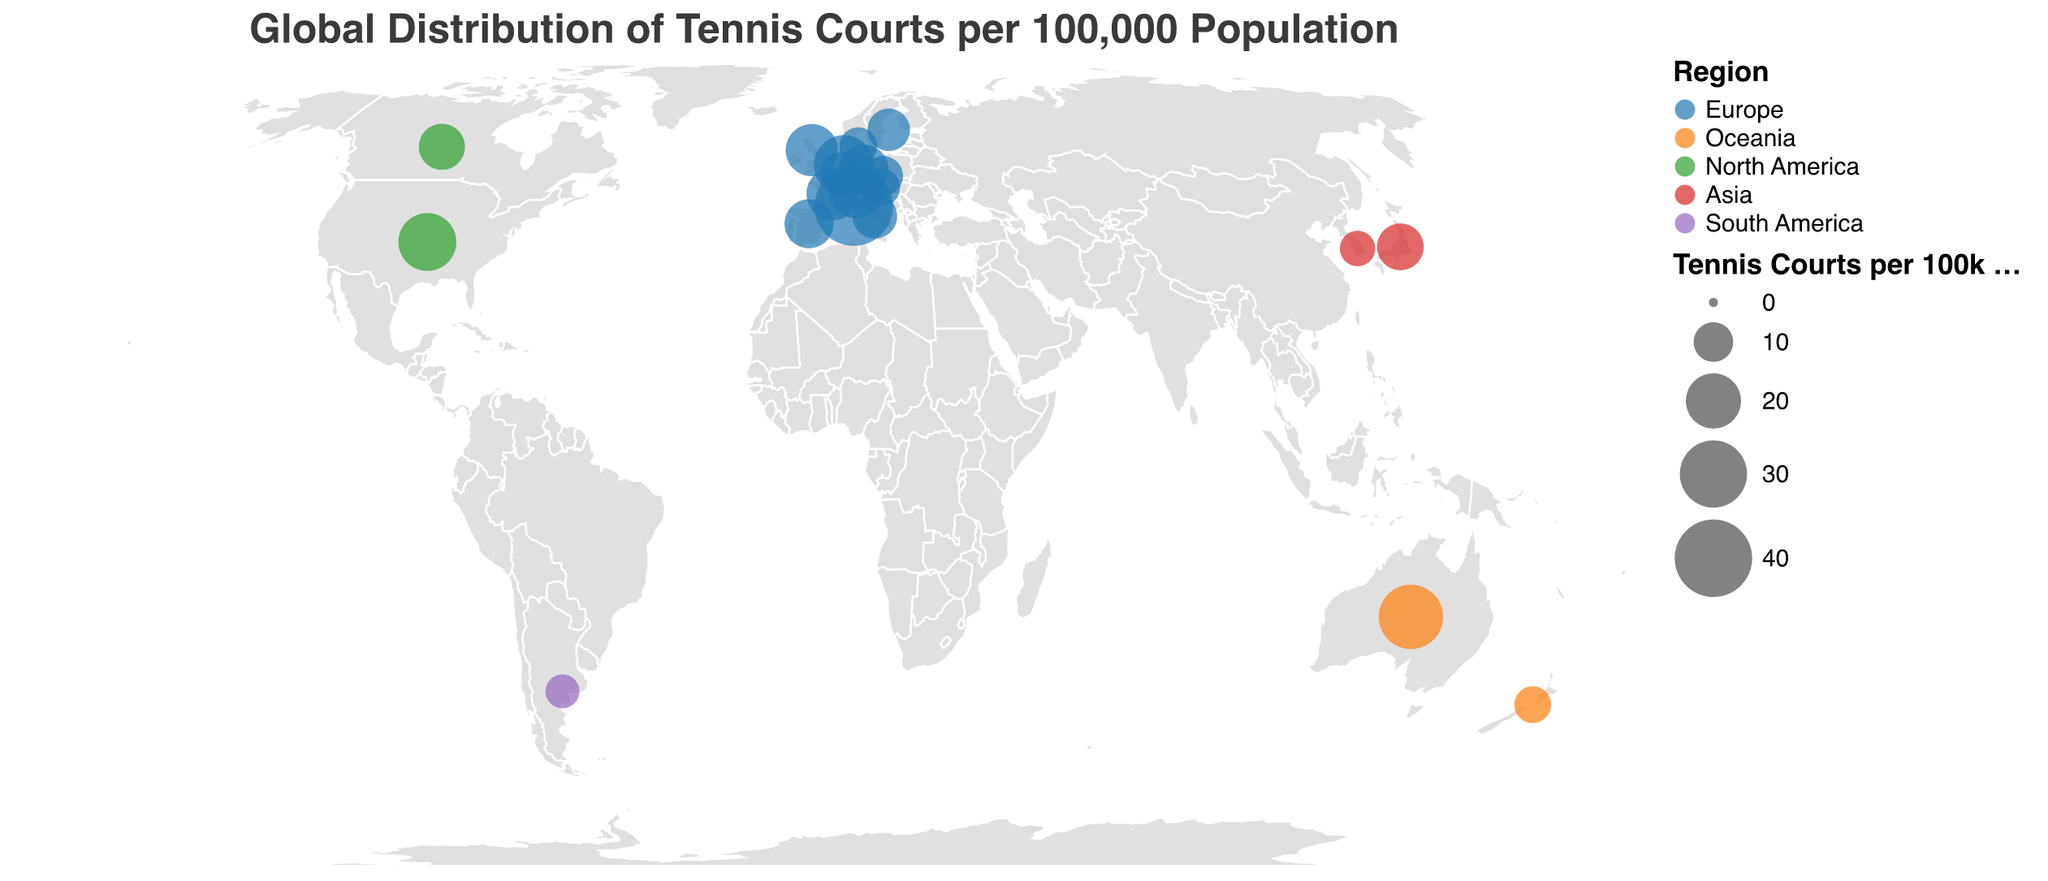What is the title of the figure? The title of the figure is displayed at the top and reads "Global Distribution of Tennis Courts per 100,000 Population".
Answer: Global Distribution of Tennis Courts per 100,000 Population Which country has the highest number of tennis courts per 100k population? By looking at the size of the circles and the tooltip information, Monaco has the highest number of tennis courts per 100k population.
Answer: Monaco How many countries from Europe are represented in the figure? From the tooltip data, the countries in Europe include Monaco, Netherlands, Switzerland, France, United Kingdom, Germany, Spain, Italy, Sweden, Belgium, Czech Republic, Austria, and Denmark, totaling 13 countries.
Answer: 13 What is the combined number of tennis courts per 100k population for Australia and New Zealand? Australia has 27.5 and New Zealand has 8.6 tennis courts per 100k population. Adding these values gives 27.5 + 8.6 = 36.1.
Answer: 36.1 Which region has the most countries represented in the figure? By counting the number of countries per region from the tooltip, Europe has the most countries represented, with a total of 13 countries.
Answer: Europe Which two countries have the closest number of tennis courts per 100k population? Switzerland with 19.6 and France with 18.3 have the closest numbers. The difference between them is 19.6 - 18.3 = 1.3.
Answer: Switzerland and France What is the average number of tennis courts per 100k population for the countries in North America? The countries in North America are the United States with 22.1 and Canada with 13.8. The average is calculated as (22.1 + 13.8) / 2 = 17.95.
Answer: 17.95 Compare the number of tennis courts per 100k population between Japan and South Korea. Which country has more? By looking at the tooltip, Japan has 14.2 and South Korea has 7.9 tennis courts per 100k population. Therefore, Japan has more.
Answer: Japan Which country in South America is represented in the figure and what is its number of tennis courts per 100k population? The only country from South America is Argentina, with 7.2 tennis courts per 100k population according to the tooltip information.
Answer: Argentina, 7.2 